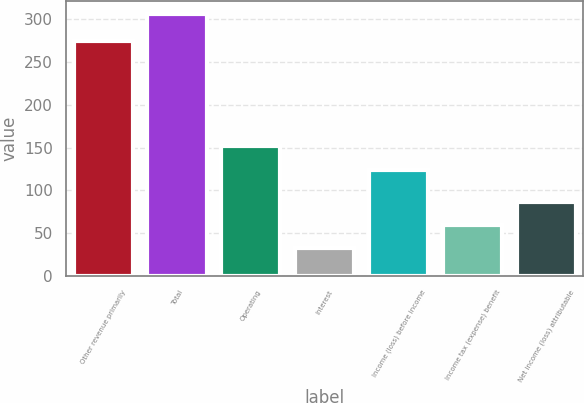Convert chart to OTSL. <chart><loc_0><loc_0><loc_500><loc_500><bar_chart><fcel>Other revenue primarily<fcel>Total<fcel>Operating<fcel>Interest<fcel>Income (loss) before income<fcel>Income tax (expense) benefit<fcel>Net income (loss) attributable<nl><fcel>274<fcel>306<fcel>151.4<fcel>32<fcel>124<fcel>59.4<fcel>86.8<nl></chart> 